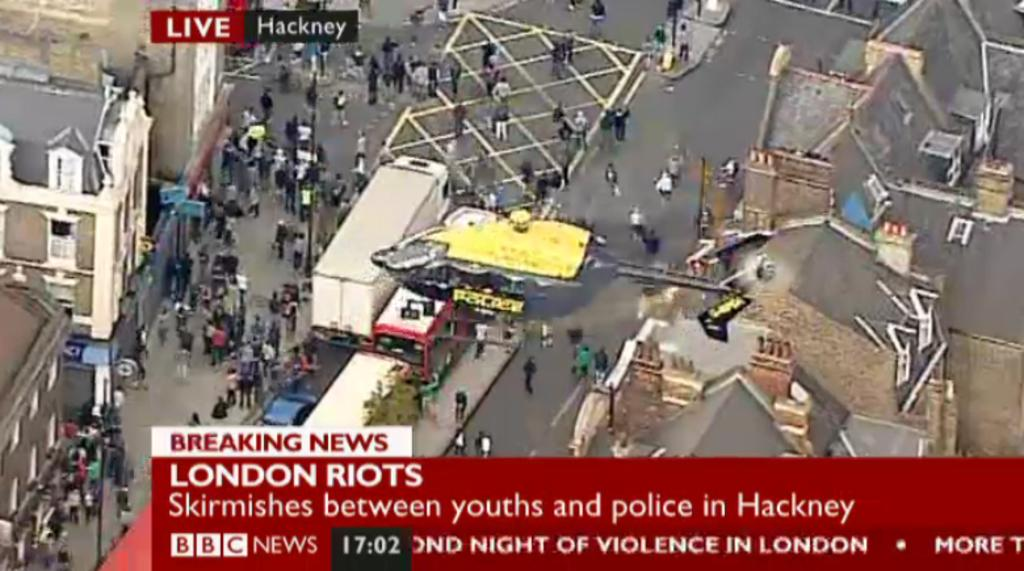What type of structures can be seen in the image? There are buildings in the image. What else can be seen moving around in the image? There are vehicles in the image. What are the vertical structures in the image used for? There are poles in the image, which are likely used for supporting wires or signs. Can you describe the people in the image? There are people on the road in the image. What information is provided at the bottom of the image? There is text visible at the bottom of the image. Where is the bath located in the image? There is no bath present in the image. How many trees can be seen in the image? There is no mention of trees in the provided facts, so we cannot determine the number of trees in the image. 